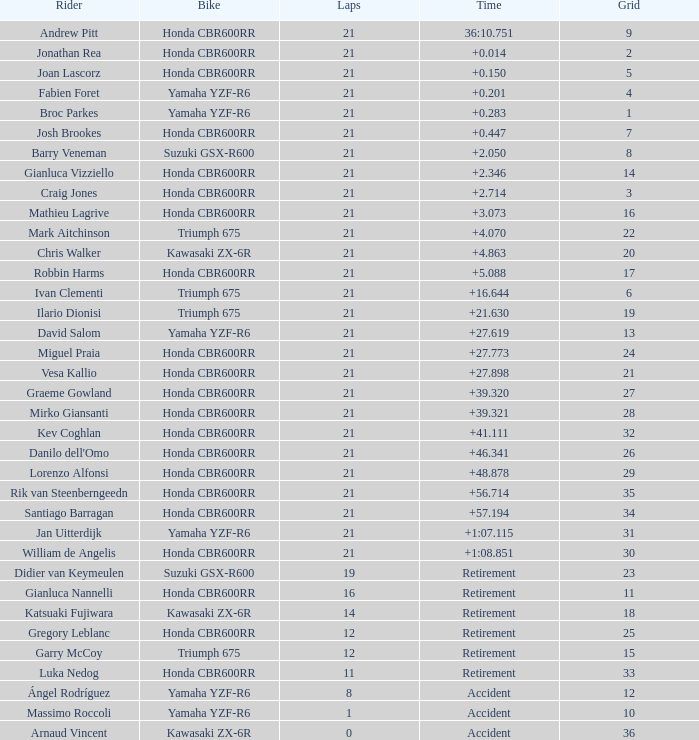What is the most number of laps run by Ilario Dionisi? 21.0. 